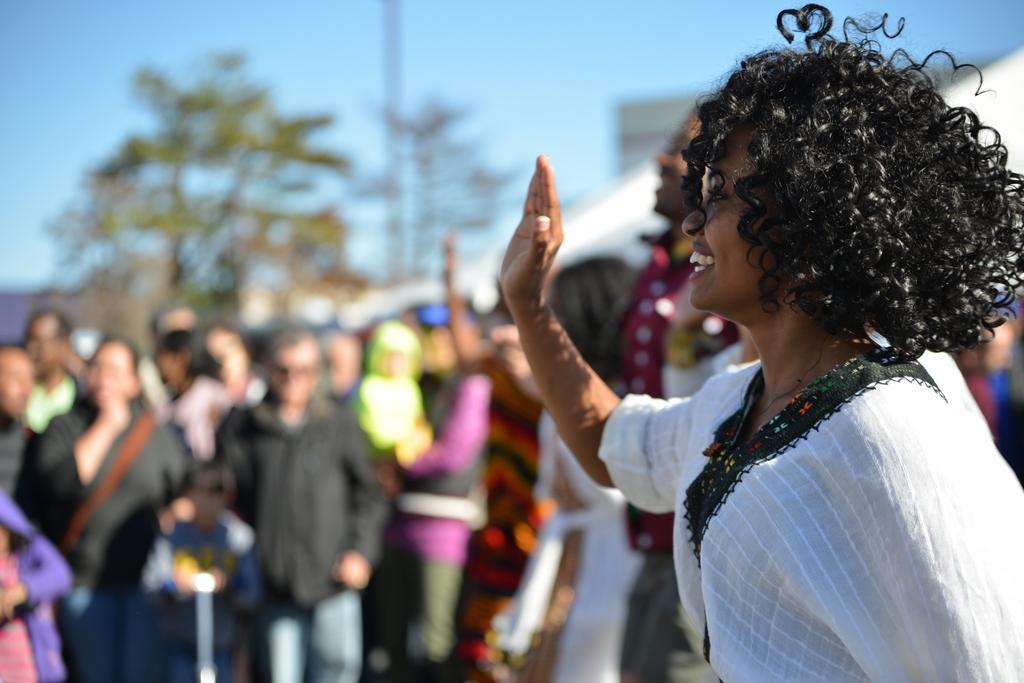Can you describe this image briefly? In this image there are a few people standing with a smile on their face, behind them there are trees and buildings. 